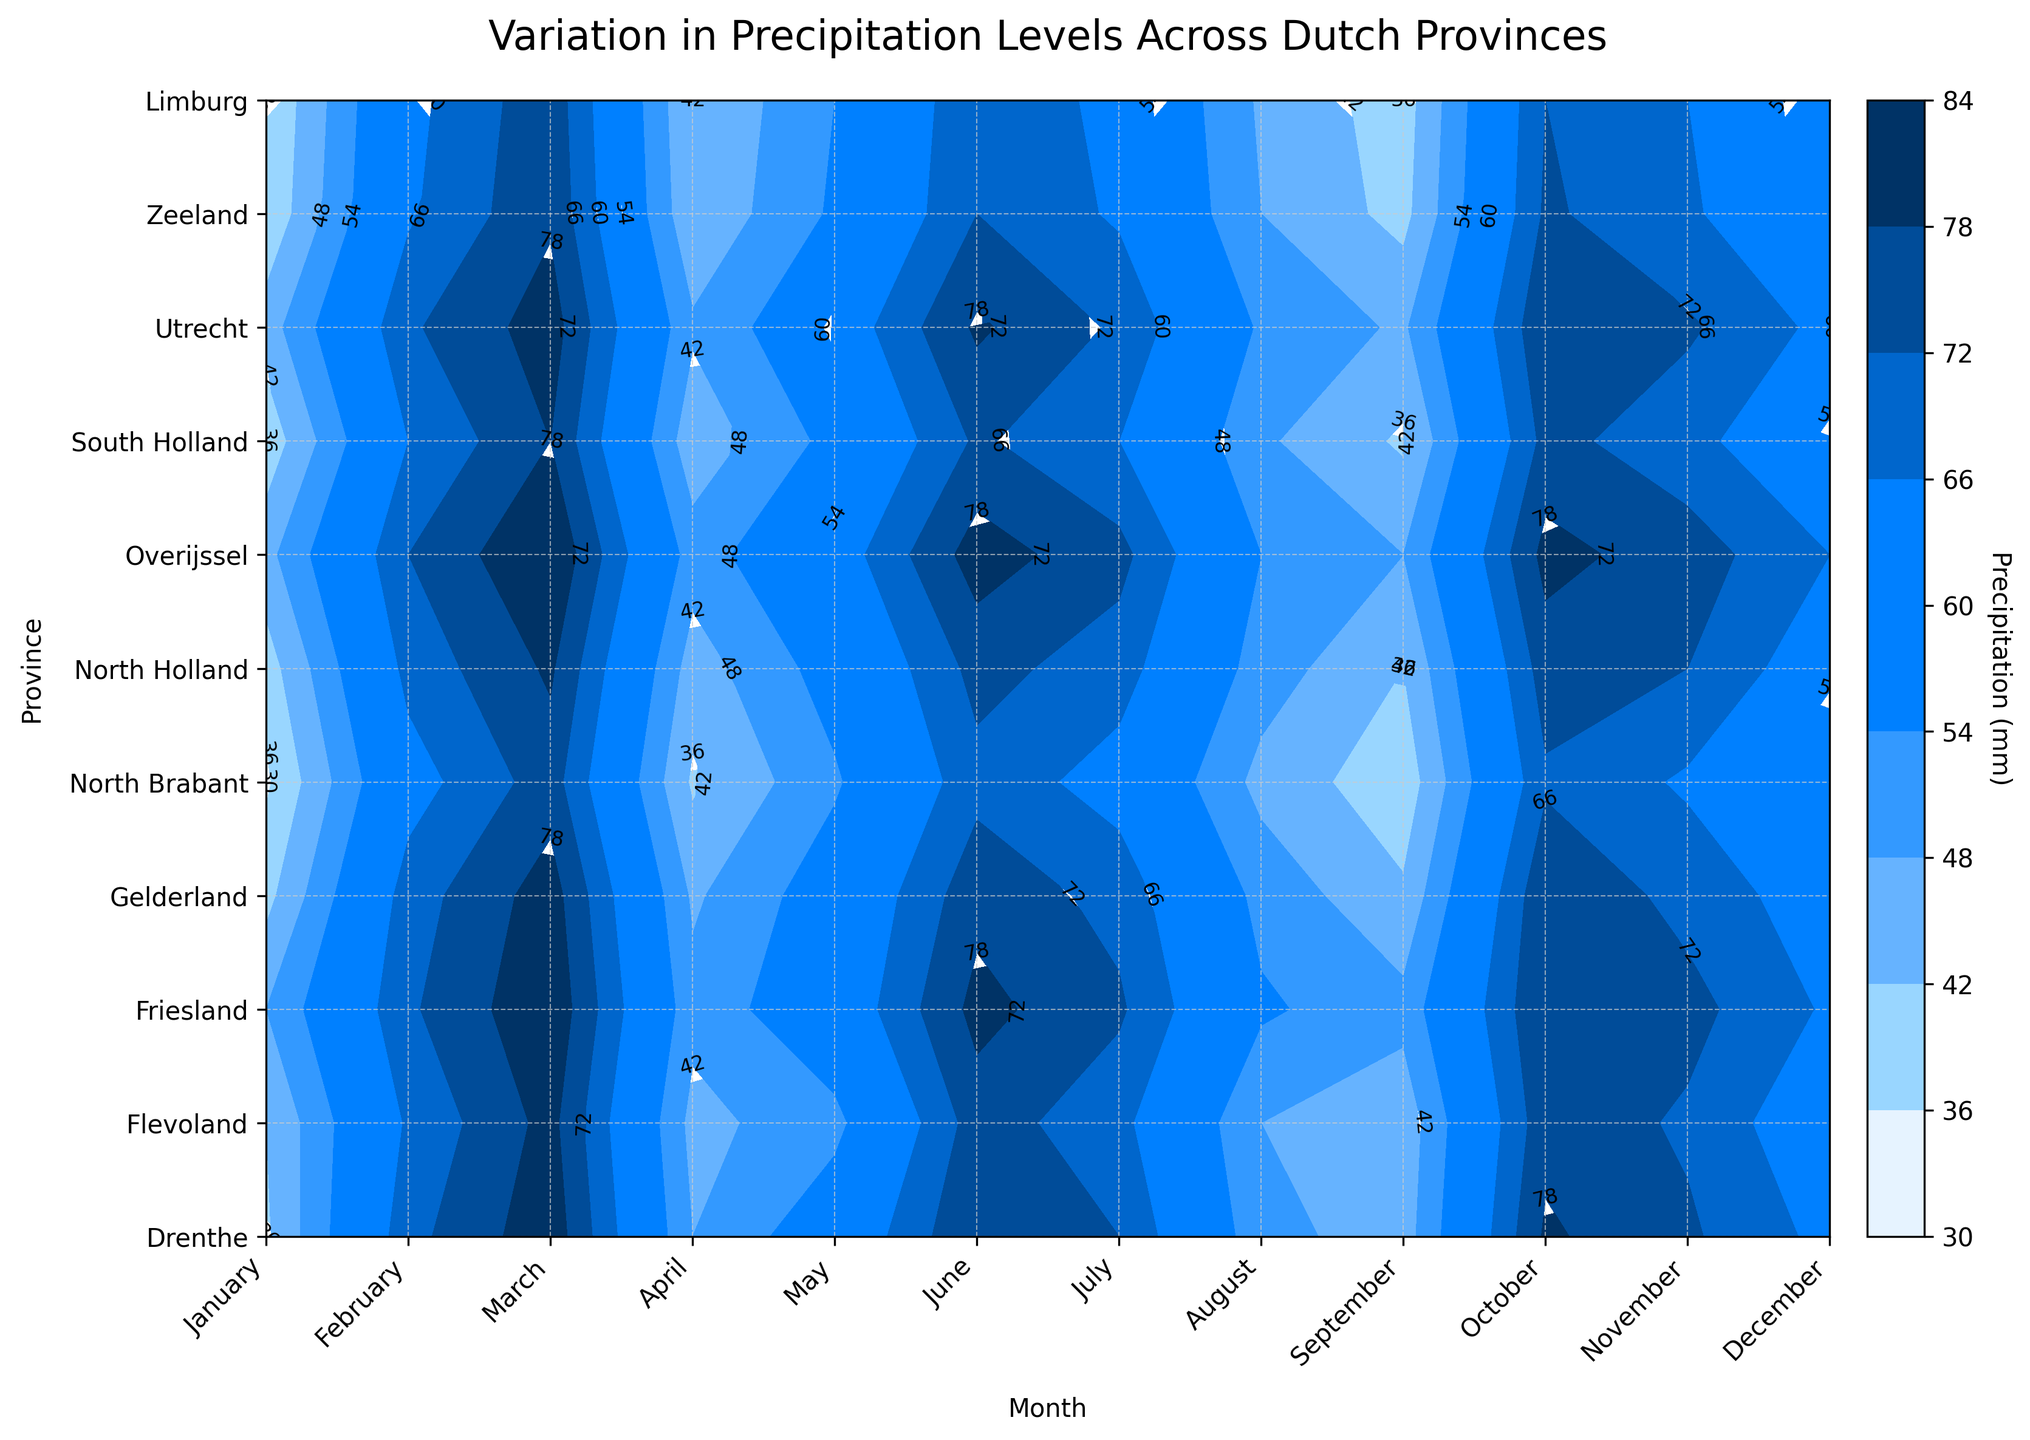What is the title of the plot? The title of the plot is usually located at the top center of the figure and is meant to give a clear idea of what the plot represents. In this case, it reads "Variation in Precipitation Levels Across Dutch Provinces".
Answer: Variation in Precipitation Levels Across Dutch Provinces Which province has the highest precipitation in December? To locate the highest precipitation in December, find the label for December on the x-axis and identify which contour in that column has the highest value. North Holland shows the highest value in December with 84 mm.
Answer: North Holland What month has the lowest precipitation in Limburg? To find this, look at the row corresponding to Limburg. Scan across all months and find the lowest contour label. The month with the lowest precipitation is April, with 35 mm.
Answer: April Compare the precipitation levels in July between North Brabant and Gelderland. Which one is higher? To compare, locate the July labels on the x-axis and follow them down to the rows for North Brabant and Gelderland. North Brabant registers at 74 mm, while Gelderland registers at 76 mm. Thus, Gelderland has the higher precipitation level.
Answer: Gelderland What is the average precipitation in Friesland for the months of June, July, and August? Add the precipitation values for June, July, and August in Friesland and then divide by 3 to get the average: (73 + 80 + 71) / 3 = 74.67 mm.
Answer: 74.67 mm Identify the month and province with the lowest overall precipitation. Scanning the entire plot for the smallest value, the values are observed lowest in Limburg in April with 35 mm. Compare each month's minimum value across all provinces.
Answer: April and Limburg Which month shows the most significant variation in precipitation among all provinces? Identify this by comparing the contour range (difference between highest and lowest values) across all provinces for each month. December shows the most significant variation with precipitation ranging from 75 mm in Limburg to 84 mm in North Holland.
Answer: December Do Drenthe and Friesland have similar precipitation patterns? To determine this, compare the contour labels of Drenthe and Friesland row-by-row. Observing the contour labels, they share similar trends with close values for each corresponding month, indicating similar precipitation patterns.
Answer: Yes Which provinces have precipitation levels higher than 70 mm in October? Locate the column for October and check which provinces have contour labels above 70 mm. The provinces are Drenthe, Gelderland, North Holland, and South Holland.
Answer: Drenthe, Gelderland, North Holland, and South Holland 